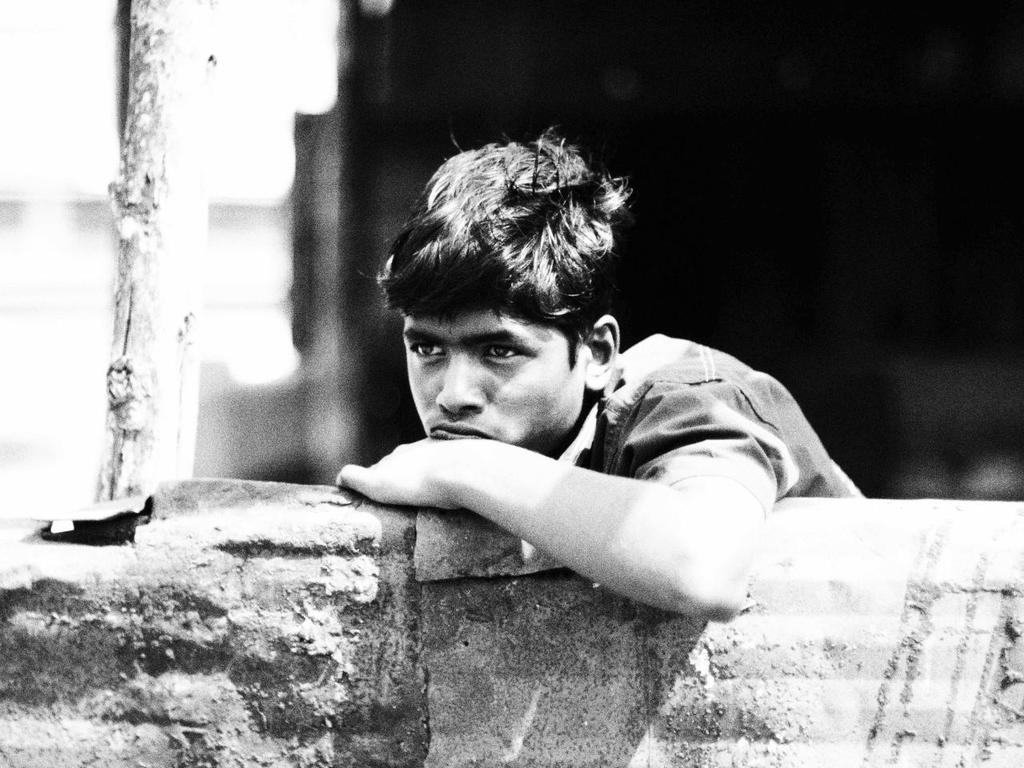What is the main subject of the image? There is a boy standing in the image. What is the boy doing in the image? The boy is leaning on a wall. What object is beside the boy? There is a stick beside the boy. Can you describe the background of the image? The background of the image is blurry. What type of canvas is the boy painting in the image? There is no canvas or painting activity present in the image. How many horses can be seen in the image? There are no horses present in the image. 